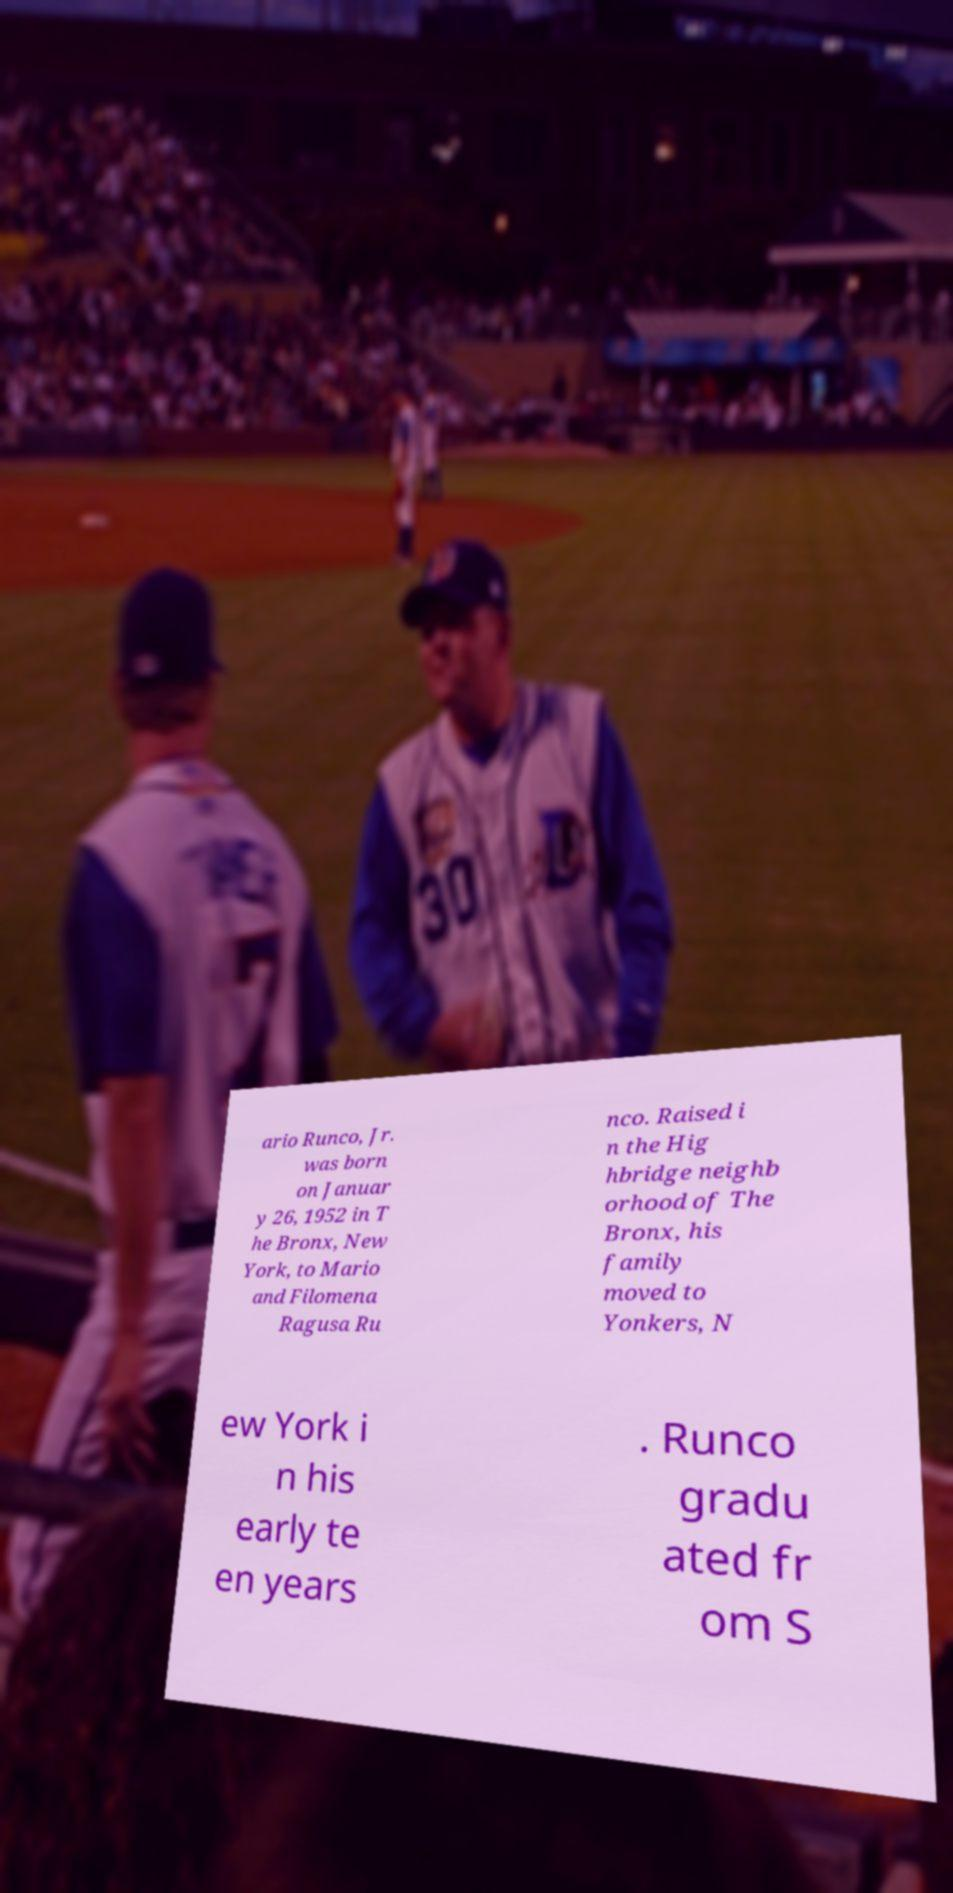Could you assist in decoding the text presented in this image and type it out clearly? ario Runco, Jr. was born on Januar y 26, 1952 in T he Bronx, New York, to Mario and Filomena Ragusa Ru nco. Raised i n the Hig hbridge neighb orhood of The Bronx, his family moved to Yonkers, N ew York i n his early te en years . Runco gradu ated fr om S 